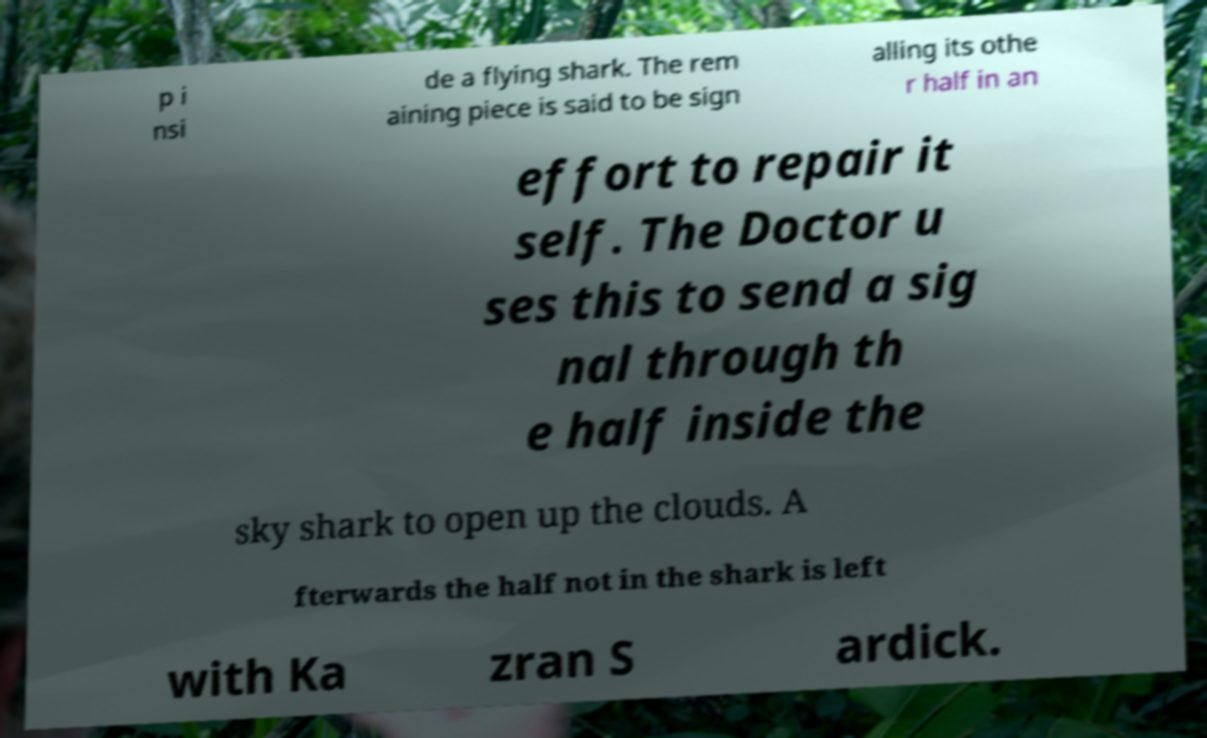What messages or text are displayed in this image? I need them in a readable, typed format. p i nsi de a flying shark. The rem aining piece is said to be sign alling its othe r half in an effort to repair it self. The Doctor u ses this to send a sig nal through th e half inside the sky shark to open up the clouds. A fterwards the half not in the shark is left with Ka zran S ardick. 